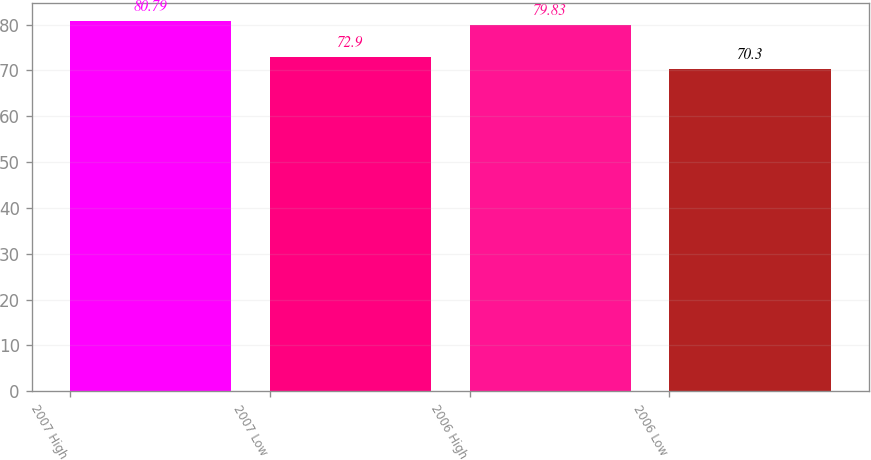<chart> <loc_0><loc_0><loc_500><loc_500><bar_chart><fcel>2007 High<fcel>2007 Low<fcel>2006 High<fcel>2006 Low<nl><fcel>80.79<fcel>72.9<fcel>79.83<fcel>70.3<nl></chart> 